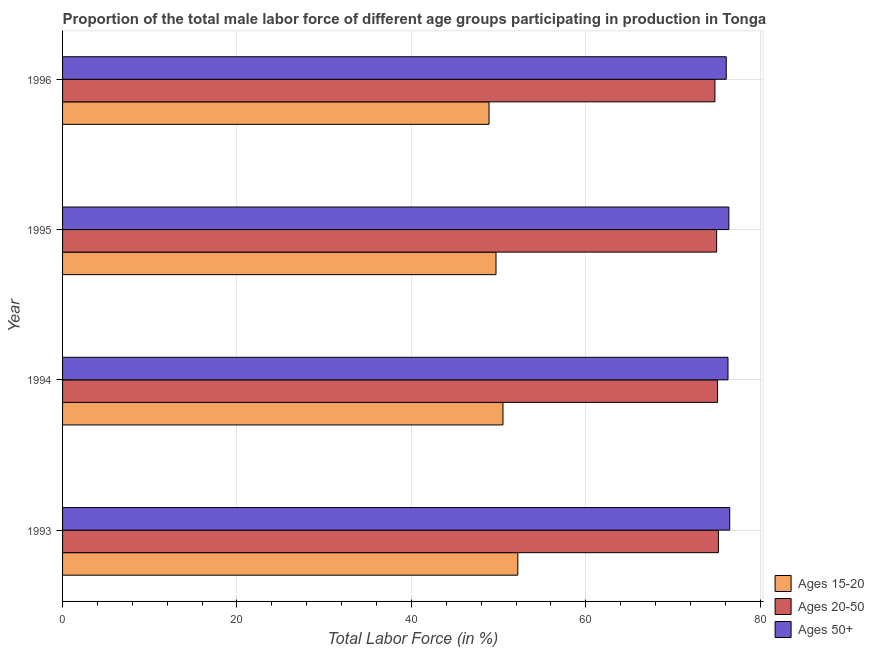How many different coloured bars are there?
Keep it short and to the point. 3. How many groups of bars are there?
Provide a short and direct response. 4. Are the number of bars on each tick of the Y-axis equal?
Ensure brevity in your answer.  Yes. How many bars are there on the 2nd tick from the top?
Your response must be concise. 3. How many bars are there on the 1st tick from the bottom?
Offer a terse response. 3. What is the percentage of male labor force within the age group 20-50 in 1995?
Offer a terse response. 75. Across all years, what is the maximum percentage of male labor force within the age group 15-20?
Your answer should be compact. 52.2. Across all years, what is the minimum percentage of male labor force above age 50?
Give a very brief answer. 76.1. In which year was the percentage of male labor force within the age group 15-20 maximum?
Ensure brevity in your answer.  1993. In which year was the percentage of male labor force within the age group 20-50 minimum?
Keep it short and to the point. 1996. What is the total percentage of male labor force within the age group 20-50 in the graph?
Your response must be concise. 300.1. What is the difference between the percentage of male labor force above age 50 in 1995 and that in 1996?
Offer a terse response. 0.3. What is the difference between the percentage of male labor force within the age group 15-20 in 1993 and the percentage of male labor force above age 50 in 1995?
Provide a succinct answer. -24.2. What is the average percentage of male labor force within the age group 20-50 per year?
Offer a very short reply. 75.03. In the year 1994, what is the difference between the percentage of male labor force above age 50 and percentage of male labor force within the age group 20-50?
Ensure brevity in your answer.  1.2. What is the ratio of the percentage of male labor force above age 50 in 1994 to that in 1996?
Your response must be concise. 1. Is the difference between the percentage of male labor force within the age group 20-50 in 1995 and 1996 greater than the difference between the percentage of male labor force above age 50 in 1995 and 1996?
Your response must be concise. No. Is the sum of the percentage of male labor force within the age group 20-50 in 1994 and 1995 greater than the maximum percentage of male labor force above age 50 across all years?
Keep it short and to the point. Yes. What does the 2nd bar from the top in 1996 represents?
Ensure brevity in your answer.  Ages 20-50. What does the 3rd bar from the bottom in 1994 represents?
Provide a succinct answer. Ages 50+. Are all the bars in the graph horizontal?
Your answer should be very brief. Yes. How many years are there in the graph?
Provide a short and direct response. 4. Are the values on the major ticks of X-axis written in scientific E-notation?
Provide a short and direct response. No. Does the graph contain any zero values?
Keep it short and to the point. No. What is the title of the graph?
Your answer should be very brief. Proportion of the total male labor force of different age groups participating in production in Tonga. What is the Total Labor Force (in %) of Ages 15-20 in 1993?
Provide a short and direct response. 52.2. What is the Total Labor Force (in %) of Ages 20-50 in 1993?
Your answer should be very brief. 75.2. What is the Total Labor Force (in %) of Ages 50+ in 1993?
Keep it short and to the point. 76.5. What is the Total Labor Force (in %) in Ages 15-20 in 1994?
Ensure brevity in your answer.  50.5. What is the Total Labor Force (in %) of Ages 20-50 in 1994?
Provide a short and direct response. 75.1. What is the Total Labor Force (in %) of Ages 50+ in 1994?
Your answer should be compact. 76.3. What is the Total Labor Force (in %) in Ages 15-20 in 1995?
Your response must be concise. 49.7. What is the Total Labor Force (in %) of Ages 50+ in 1995?
Provide a succinct answer. 76.4. What is the Total Labor Force (in %) of Ages 15-20 in 1996?
Keep it short and to the point. 48.9. What is the Total Labor Force (in %) in Ages 20-50 in 1996?
Provide a succinct answer. 74.8. What is the Total Labor Force (in %) in Ages 50+ in 1996?
Ensure brevity in your answer.  76.1. Across all years, what is the maximum Total Labor Force (in %) of Ages 15-20?
Offer a terse response. 52.2. Across all years, what is the maximum Total Labor Force (in %) in Ages 20-50?
Your answer should be compact. 75.2. Across all years, what is the maximum Total Labor Force (in %) of Ages 50+?
Keep it short and to the point. 76.5. Across all years, what is the minimum Total Labor Force (in %) in Ages 15-20?
Give a very brief answer. 48.9. Across all years, what is the minimum Total Labor Force (in %) in Ages 20-50?
Make the answer very short. 74.8. Across all years, what is the minimum Total Labor Force (in %) in Ages 50+?
Ensure brevity in your answer.  76.1. What is the total Total Labor Force (in %) in Ages 15-20 in the graph?
Your answer should be very brief. 201.3. What is the total Total Labor Force (in %) of Ages 20-50 in the graph?
Provide a succinct answer. 300.1. What is the total Total Labor Force (in %) of Ages 50+ in the graph?
Your answer should be very brief. 305.3. What is the difference between the Total Labor Force (in %) of Ages 15-20 in 1993 and that in 1995?
Offer a very short reply. 2.5. What is the difference between the Total Labor Force (in %) in Ages 50+ in 1993 and that in 1995?
Keep it short and to the point. 0.1. What is the difference between the Total Labor Force (in %) of Ages 20-50 in 1993 and that in 1996?
Make the answer very short. 0.4. What is the difference between the Total Labor Force (in %) in Ages 15-20 in 1994 and that in 1995?
Offer a very short reply. 0.8. What is the difference between the Total Labor Force (in %) in Ages 20-50 in 1994 and that in 1995?
Give a very brief answer. 0.1. What is the difference between the Total Labor Force (in %) in Ages 15-20 in 1994 and that in 1996?
Provide a short and direct response. 1.6. What is the difference between the Total Labor Force (in %) of Ages 20-50 in 1994 and that in 1996?
Give a very brief answer. 0.3. What is the difference between the Total Labor Force (in %) in Ages 15-20 in 1995 and that in 1996?
Offer a very short reply. 0.8. What is the difference between the Total Labor Force (in %) in Ages 20-50 in 1995 and that in 1996?
Your answer should be very brief. 0.2. What is the difference between the Total Labor Force (in %) of Ages 15-20 in 1993 and the Total Labor Force (in %) of Ages 20-50 in 1994?
Keep it short and to the point. -22.9. What is the difference between the Total Labor Force (in %) in Ages 15-20 in 1993 and the Total Labor Force (in %) in Ages 50+ in 1994?
Provide a short and direct response. -24.1. What is the difference between the Total Labor Force (in %) of Ages 15-20 in 1993 and the Total Labor Force (in %) of Ages 20-50 in 1995?
Keep it short and to the point. -22.8. What is the difference between the Total Labor Force (in %) of Ages 15-20 in 1993 and the Total Labor Force (in %) of Ages 50+ in 1995?
Your response must be concise. -24.2. What is the difference between the Total Labor Force (in %) of Ages 15-20 in 1993 and the Total Labor Force (in %) of Ages 20-50 in 1996?
Provide a succinct answer. -22.6. What is the difference between the Total Labor Force (in %) in Ages 15-20 in 1993 and the Total Labor Force (in %) in Ages 50+ in 1996?
Offer a terse response. -23.9. What is the difference between the Total Labor Force (in %) in Ages 20-50 in 1993 and the Total Labor Force (in %) in Ages 50+ in 1996?
Your answer should be very brief. -0.9. What is the difference between the Total Labor Force (in %) of Ages 15-20 in 1994 and the Total Labor Force (in %) of Ages 20-50 in 1995?
Provide a short and direct response. -24.5. What is the difference between the Total Labor Force (in %) of Ages 15-20 in 1994 and the Total Labor Force (in %) of Ages 50+ in 1995?
Offer a terse response. -25.9. What is the difference between the Total Labor Force (in %) in Ages 20-50 in 1994 and the Total Labor Force (in %) in Ages 50+ in 1995?
Offer a terse response. -1.3. What is the difference between the Total Labor Force (in %) in Ages 15-20 in 1994 and the Total Labor Force (in %) in Ages 20-50 in 1996?
Offer a very short reply. -24.3. What is the difference between the Total Labor Force (in %) in Ages 15-20 in 1994 and the Total Labor Force (in %) in Ages 50+ in 1996?
Your answer should be very brief. -25.6. What is the difference between the Total Labor Force (in %) of Ages 20-50 in 1994 and the Total Labor Force (in %) of Ages 50+ in 1996?
Your answer should be compact. -1. What is the difference between the Total Labor Force (in %) in Ages 15-20 in 1995 and the Total Labor Force (in %) in Ages 20-50 in 1996?
Give a very brief answer. -25.1. What is the difference between the Total Labor Force (in %) of Ages 15-20 in 1995 and the Total Labor Force (in %) of Ages 50+ in 1996?
Provide a short and direct response. -26.4. What is the average Total Labor Force (in %) in Ages 15-20 per year?
Your answer should be very brief. 50.33. What is the average Total Labor Force (in %) in Ages 20-50 per year?
Keep it short and to the point. 75.03. What is the average Total Labor Force (in %) of Ages 50+ per year?
Give a very brief answer. 76.33. In the year 1993, what is the difference between the Total Labor Force (in %) of Ages 15-20 and Total Labor Force (in %) of Ages 20-50?
Make the answer very short. -23. In the year 1993, what is the difference between the Total Labor Force (in %) in Ages 15-20 and Total Labor Force (in %) in Ages 50+?
Give a very brief answer. -24.3. In the year 1993, what is the difference between the Total Labor Force (in %) of Ages 20-50 and Total Labor Force (in %) of Ages 50+?
Give a very brief answer. -1.3. In the year 1994, what is the difference between the Total Labor Force (in %) in Ages 15-20 and Total Labor Force (in %) in Ages 20-50?
Ensure brevity in your answer.  -24.6. In the year 1994, what is the difference between the Total Labor Force (in %) in Ages 15-20 and Total Labor Force (in %) in Ages 50+?
Offer a terse response. -25.8. In the year 1995, what is the difference between the Total Labor Force (in %) in Ages 15-20 and Total Labor Force (in %) in Ages 20-50?
Ensure brevity in your answer.  -25.3. In the year 1995, what is the difference between the Total Labor Force (in %) in Ages 15-20 and Total Labor Force (in %) in Ages 50+?
Make the answer very short. -26.7. In the year 1996, what is the difference between the Total Labor Force (in %) in Ages 15-20 and Total Labor Force (in %) in Ages 20-50?
Your response must be concise. -25.9. In the year 1996, what is the difference between the Total Labor Force (in %) of Ages 15-20 and Total Labor Force (in %) of Ages 50+?
Make the answer very short. -27.2. In the year 1996, what is the difference between the Total Labor Force (in %) of Ages 20-50 and Total Labor Force (in %) of Ages 50+?
Offer a very short reply. -1.3. What is the ratio of the Total Labor Force (in %) in Ages 15-20 in 1993 to that in 1994?
Make the answer very short. 1.03. What is the ratio of the Total Labor Force (in %) in Ages 15-20 in 1993 to that in 1995?
Offer a very short reply. 1.05. What is the ratio of the Total Labor Force (in %) in Ages 15-20 in 1993 to that in 1996?
Your answer should be compact. 1.07. What is the ratio of the Total Labor Force (in %) in Ages 20-50 in 1993 to that in 1996?
Your answer should be compact. 1.01. What is the ratio of the Total Labor Force (in %) of Ages 50+ in 1993 to that in 1996?
Offer a terse response. 1.01. What is the ratio of the Total Labor Force (in %) in Ages 15-20 in 1994 to that in 1995?
Your answer should be compact. 1.02. What is the ratio of the Total Labor Force (in %) of Ages 15-20 in 1994 to that in 1996?
Provide a succinct answer. 1.03. What is the ratio of the Total Labor Force (in %) in Ages 15-20 in 1995 to that in 1996?
Ensure brevity in your answer.  1.02. What is the difference between the highest and the second highest Total Labor Force (in %) in Ages 15-20?
Your response must be concise. 1.7. What is the difference between the highest and the second highest Total Labor Force (in %) of Ages 50+?
Your response must be concise. 0.1. What is the difference between the highest and the lowest Total Labor Force (in %) in Ages 20-50?
Your response must be concise. 0.4. What is the difference between the highest and the lowest Total Labor Force (in %) in Ages 50+?
Your answer should be very brief. 0.4. 